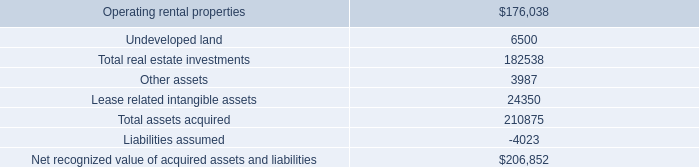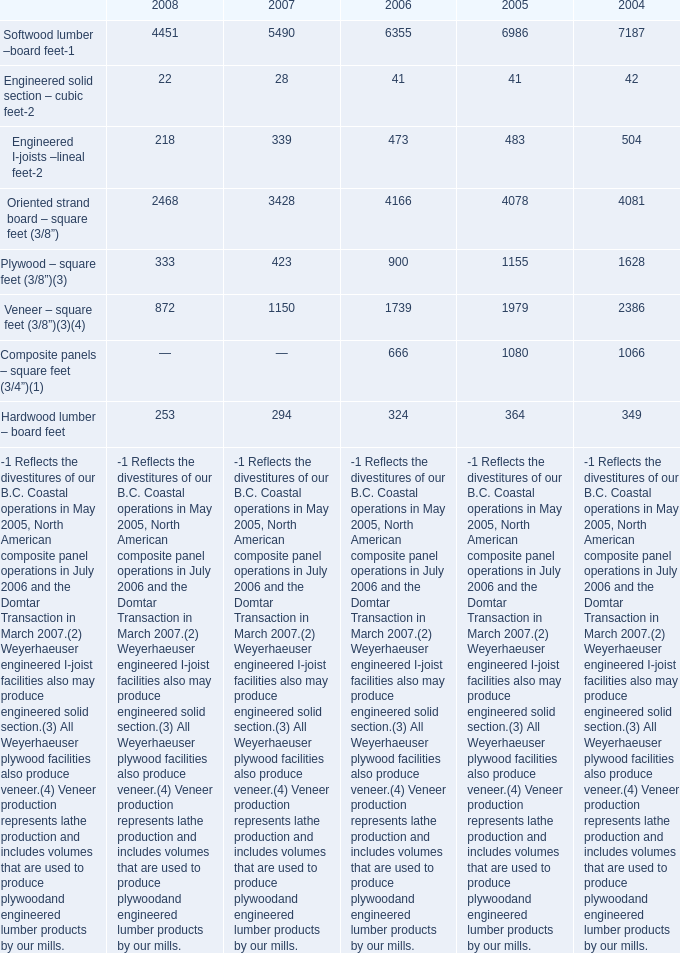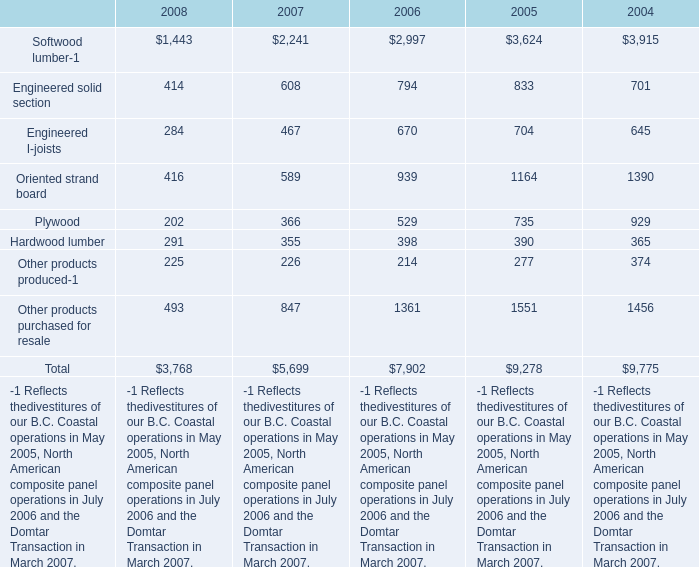In which year is Softwood lumber –board feet- greater than 7000? 
Answer: 2004. 